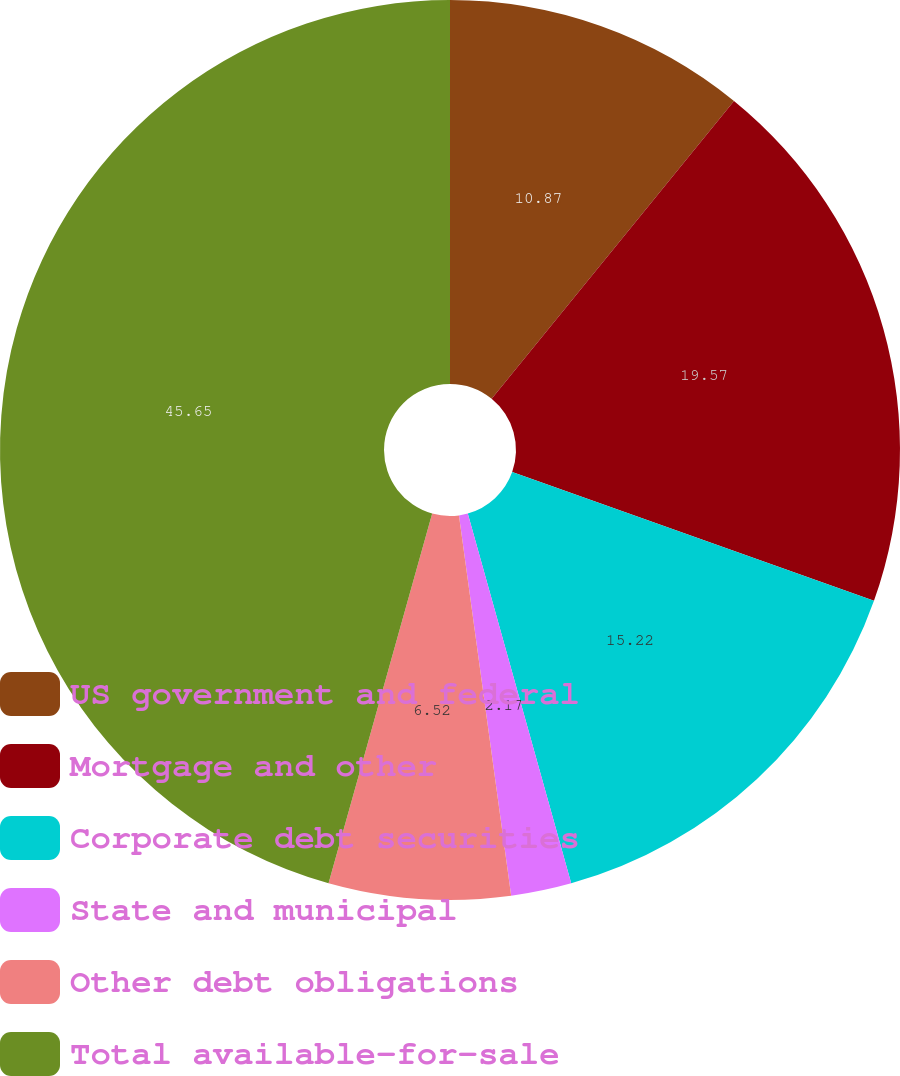Convert chart. <chart><loc_0><loc_0><loc_500><loc_500><pie_chart><fcel>US government and federal<fcel>Mortgage and other<fcel>Corporate debt securities<fcel>State and municipal<fcel>Other debt obligations<fcel>Total available-for-sale<nl><fcel>10.87%<fcel>19.57%<fcel>15.22%<fcel>2.17%<fcel>6.52%<fcel>45.65%<nl></chart> 